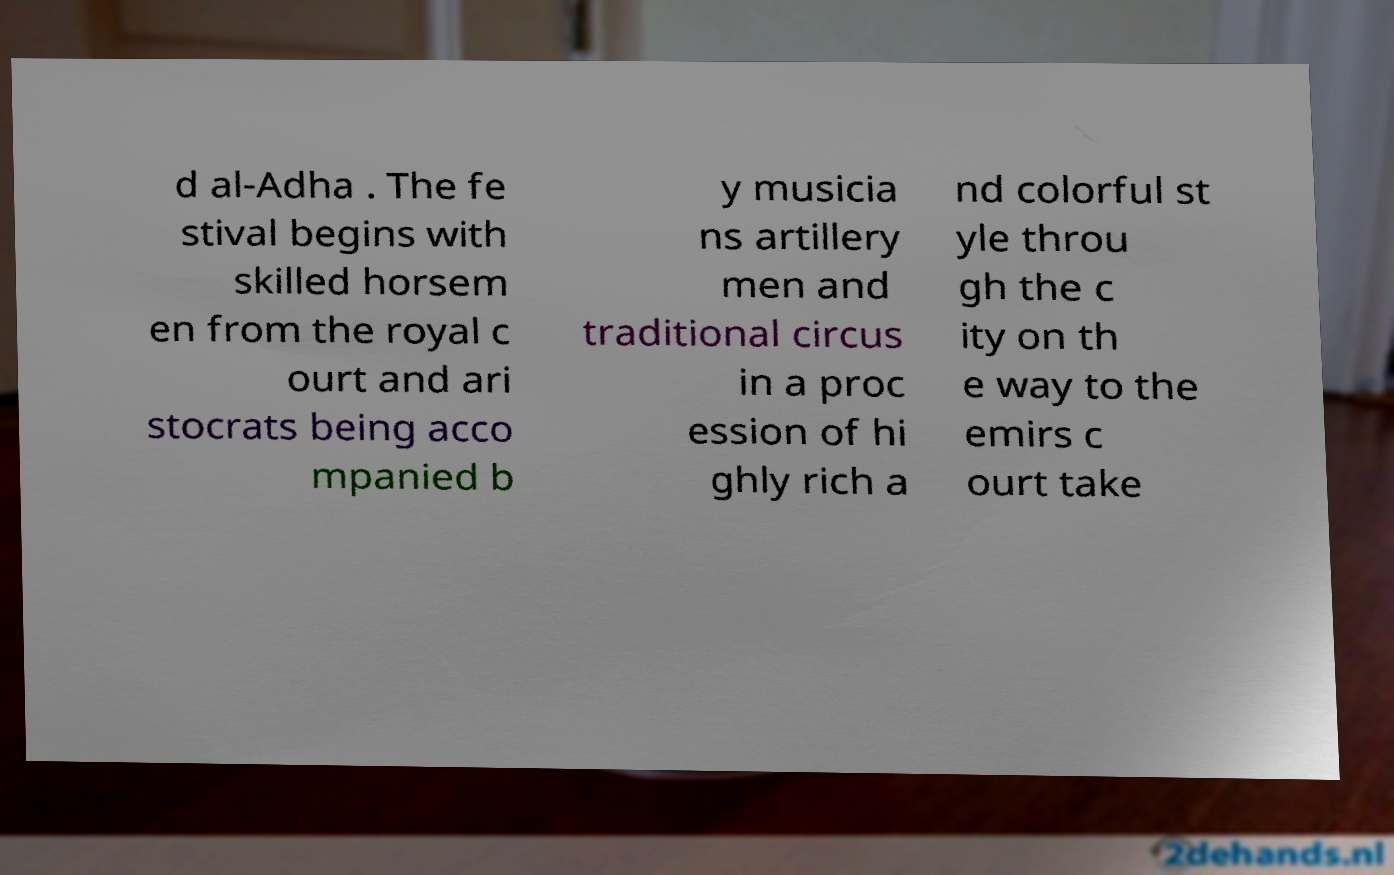For documentation purposes, I need the text within this image transcribed. Could you provide that? d al-Adha . The fe stival begins with skilled horsem en from the royal c ourt and ari stocrats being acco mpanied b y musicia ns artillery men and traditional circus in a proc ession of hi ghly rich a nd colorful st yle throu gh the c ity on th e way to the emirs c ourt take 